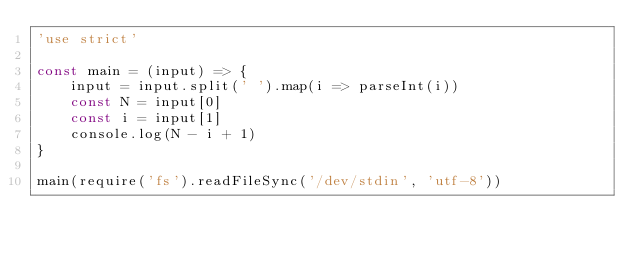<code> <loc_0><loc_0><loc_500><loc_500><_JavaScript_>'use strict'

const main = (input) => {
    input = input.split(' ').map(i => parseInt(i))
    const N = input[0]
    const i = input[1]
    console.log(N - i + 1)
}

main(require('fs').readFileSync('/dev/stdin', 'utf-8'))</code> 